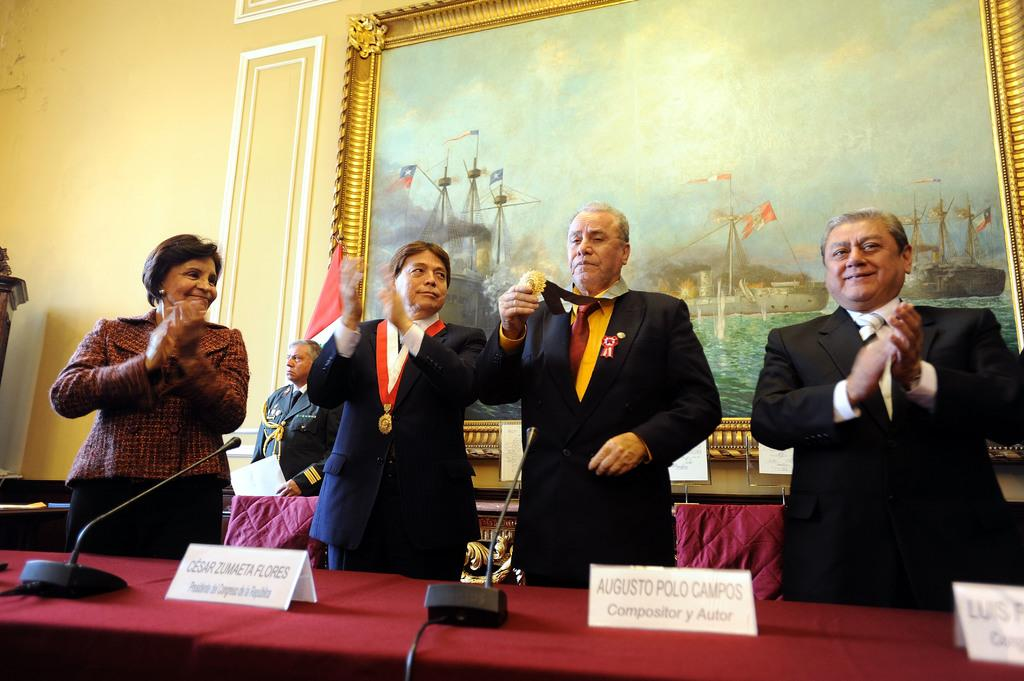How many people are standing at the table in the image? There are multiple persons standing at the table in the image. What objects are present on the table? Name boards and microphones (mics) are on the table. Can you describe the background of the image? There is a person visible in the background, along with a painting and a wall. What type of underwear is the person in the background wearing? There is no information about the person's underwear in the image, as it is not visible or mentioned in the provided facts. 